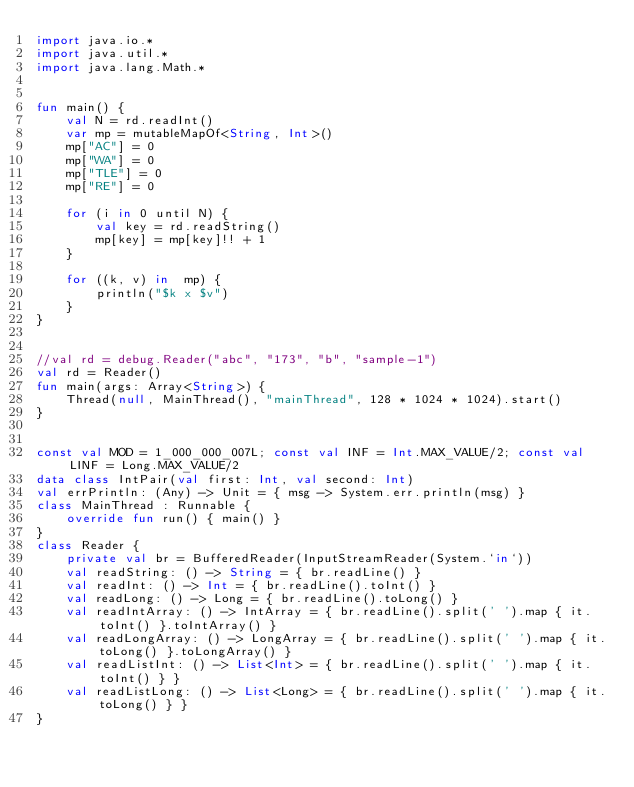Convert code to text. <code><loc_0><loc_0><loc_500><loc_500><_Kotlin_>import java.io.*
import java.util.*
import java.lang.Math.*


fun main() {
    val N = rd.readInt()
    var mp = mutableMapOf<String, Int>()
    mp["AC"] = 0
    mp["WA"] = 0
    mp["TLE"] = 0
    mp["RE"] = 0

    for (i in 0 until N) {
        val key = rd.readString()
        mp[key] = mp[key]!! + 1
    }

    for ((k, v) in  mp) {
        println("$k x $v")
    }
}


//val rd = debug.Reader("abc", "173", "b", "sample-1")
val rd = Reader()
fun main(args: Array<String>) {
    Thread(null, MainThread(), "mainThread", 128 * 1024 * 1024).start()
}


const val MOD = 1_000_000_007L; const val INF = Int.MAX_VALUE/2; const val LINF = Long.MAX_VALUE/2
data class IntPair(val first: Int, val second: Int)
val errPrintln: (Any) -> Unit = { msg -> System.err.println(msg) }
class MainThread : Runnable {
    override fun run() { main() }
}
class Reader {
    private val br = BufferedReader(InputStreamReader(System.`in`))
    val readString: () -> String = { br.readLine() }
    val readInt: () -> Int = { br.readLine().toInt() }
    val readLong: () -> Long = { br.readLine().toLong() }
    val readIntArray: () -> IntArray = { br.readLine().split(' ').map { it.toInt() }.toIntArray() }
    val readLongArray: () -> LongArray = { br.readLine().split(' ').map { it.toLong() }.toLongArray() }
    val readListInt: () -> List<Int> = { br.readLine().split(' ').map { it.toInt() } }
    val readListLong: () -> List<Long> = { br.readLine().split(' ').map { it.toLong() } }
}
</code> 